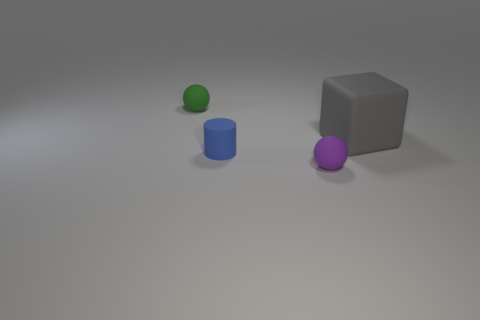The matte cube has what color?
Your response must be concise. Gray. The thing to the right of the matte sphere in front of the big object is what color?
Give a very brief answer. Gray. Is there a object made of the same material as the cylinder?
Offer a very short reply. Yes. What is the material of the object on the right side of the small sphere that is in front of the green rubber ball?
Give a very brief answer. Rubber. What number of small green objects have the same shape as the small purple object?
Keep it short and to the point. 1. The small blue matte object has what shape?
Your answer should be very brief. Cylinder. Are there fewer gray rubber cubes than big purple metallic cylinders?
Your response must be concise. No. Are there any other things that are the same size as the block?
Offer a terse response. No. Is the number of gray blocks greater than the number of rubber spheres?
Your answer should be compact. No. How many other things are the same color as the large rubber block?
Offer a terse response. 0. 